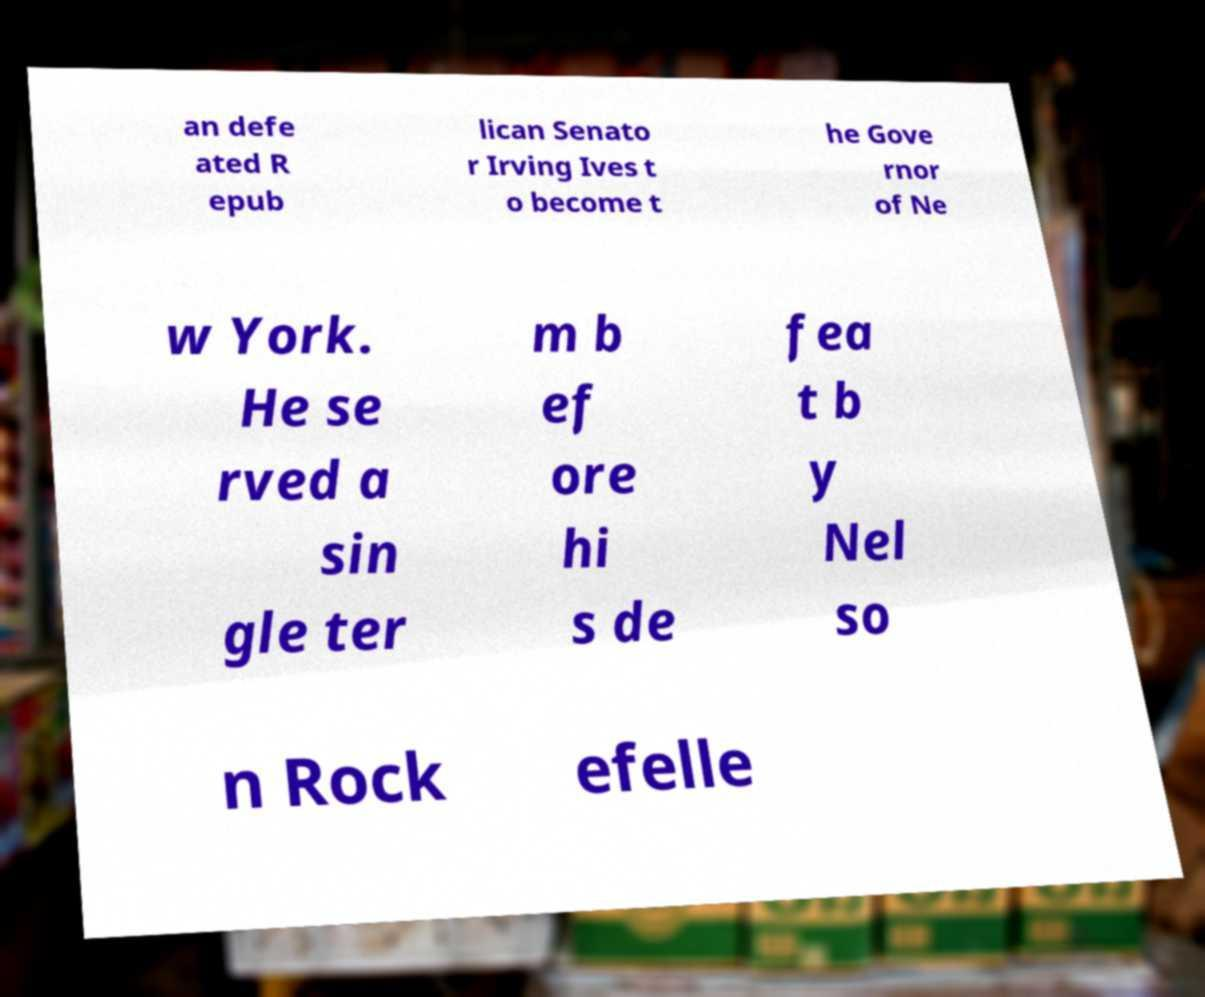What messages or text are displayed in this image? I need them in a readable, typed format. an defe ated R epub lican Senato r Irving Ives t o become t he Gove rnor of Ne w York. He se rved a sin gle ter m b ef ore hi s de fea t b y Nel so n Rock efelle 